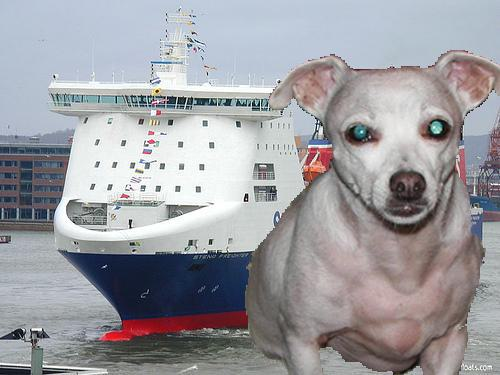How many unicorns would there be in the image if someone deleted zero unicorns from the picture? There would still be the same number of unicorns in the image after deleting zero unicorns, which is zero since there are no unicorns present in the picture. 